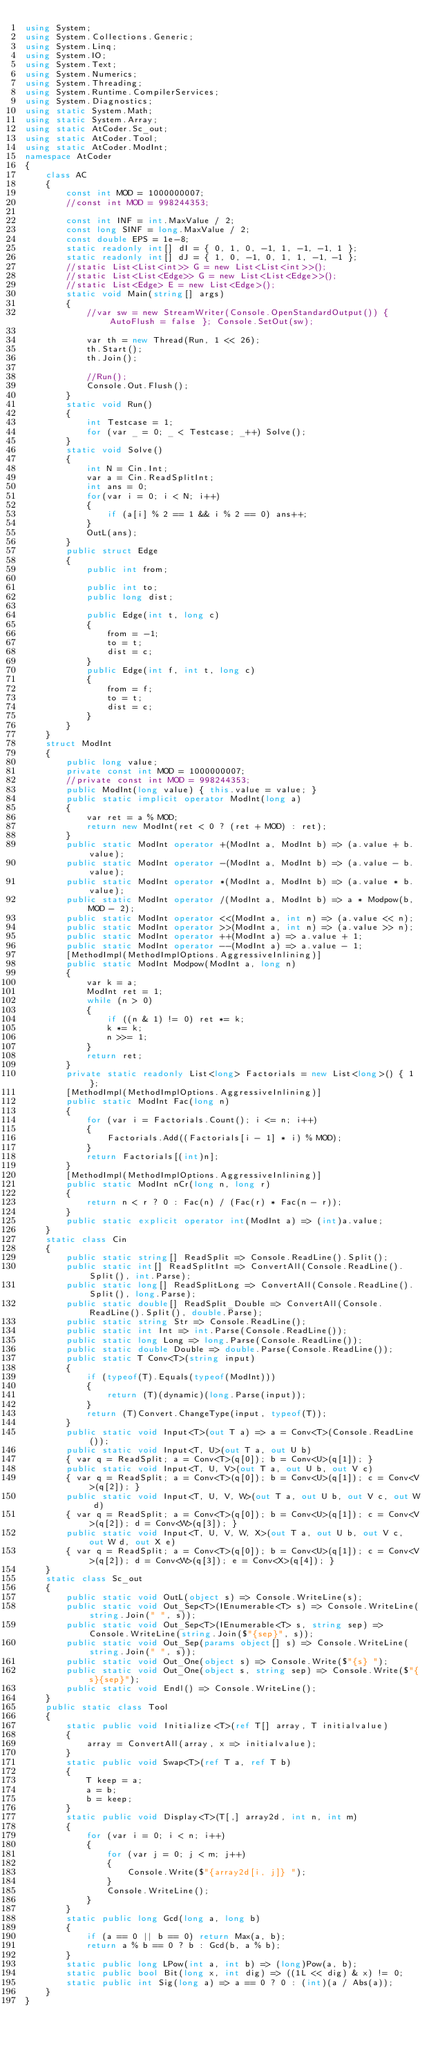<code> <loc_0><loc_0><loc_500><loc_500><_C#_>using System;
using System.Collections.Generic;
using System.Linq;
using System.IO;
using System.Text;
using System.Numerics;
using System.Threading;
using System.Runtime.CompilerServices;
using System.Diagnostics;
using static System.Math;
using static System.Array;
using static AtCoder.Sc_out;
using static AtCoder.Tool;
using static AtCoder.ModInt;
namespace AtCoder
{
    class AC
    {
        const int MOD = 1000000007;
        //const int MOD = 998244353;

        const int INF = int.MaxValue / 2;
        const long SINF = long.MaxValue / 2;
        const double EPS = 1e-8;
        static readonly int[] dI = { 0, 1, 0, -1, 1, -1, -1, 1 };
        static readonly int[] dJ = { 1, 0, -1, 0, 1, 1, -1, -1 };
        //static List<List<int>> G = new List<List<int>>();
        //static List<List<Edge>> G = new List<List<Edge>>();
        //static List<Edge> E = new List<Edge>();
        static void Main(string[] args)
        {
            //var sw = new StreamWriter(Console.OpenStandardOutput()) { AutoFlush = false }; Console.SetOut(sw);

            var th = new Thread(Run, 1 << 26);
            th.Start();
            th.Join();

            //Run();
            Console.Out.Flush();
        }
        static void Run()
        {
            int Testcase = 1;
            for (var _ = 0; _ < Testcase; _++) Solve();
        }
        static void Solve()
        {
            int N = Cin.Int;
            var a = Cin.ReadSplitInt;
            int ans = 0;
            for(var i = 0; i < N; i++)
            {
                if (a[i] % 2 == 1 && i % 2 == 0) ans++;
            }
            OutL(ans);
        }
        public struct Edge
        {
            public int from;

            public int to;
            public long dist;

            public Edge(int t, long c)
            {
                from = -1;
                to = t;
                dist = c;
            }
            public Edge(int f, int t, long c)
            {
                from = f;
                to = t;
                dist = c;
            }
        }
    }
    struct ModInt
    {
        public long value;
        private const int MOD = 1000000007;
        //private const int MOD = 998244353;
        public ModInt(long value) { this.value = value; }
        public static implicit operator ModInt(long a)
        {
            var ret = a % MOD;
            return new ModInt(ret < 0 ? (ret + MOD) : ret);
        }
        public static ModInt operator +(ModInt a, ModInt b) => (a.value + b.value);
        public static ModInt operator -(ModInt a, ModInt b) => (a.value - b.value);
        public static ModInt operator *(ModInt a, ModInt b) => (a.value * b.value);
        public static ModInt operator /(ModInt a, ModInt b) => a * Modpow(b, MOD - 2);
        public static ModInt operator <<(ModInt a, int n) => (a.value << n);
        public static ModInt operator >>(ModInt a, int n) => (a.value >> n);
        public static ModInt operator ++(ModInt a) => a.value + 1;
        public static ModInt operator --(ModInt a) => a.value - 1;
        [MethodImpl(MethodImplOptions.AggressiveInlining)]
        public static ModInt Modpow(ModInt a, long n)
        {
            var k = a;
            ModInt ret = 1;
            while (n > 0)
            {
                if ((n & 1) != 0) ret *= k;
                k *= k;
                n >>= 1;
            }
            return ret;
        }
        private static readonly List<long> Factorials = new List<long>() { 1 };
        [MethodImpl(MethodImplOptions.AggressiveInlining)]
        public static ModInt Fac(long n)
        {
            for (var i = Factorials.Count(); i <= n; i++)
            {
                Factorials.Add((Factorials[i - 1] * i) % MOD);
            }
            return Factorials[(int)n];
        }
        [MethodImpl(MethodImplOptions.AggressiveInlining)]
        public static ModInt nCr(long n, long r)
        {
            return n < r ? 0 : Fac(n) / (Fac(r) * Fac(n - r));
        }
        public static explicit operator int(ModInt a) => (int)a.value;
    }
    static class Cin
    {
        public static string[] ReadSplit => Console.ReadLine().Split();
        public static int[] ReadSplitInt => ConvertAll(Console.ReadLine().Split(), int.Parse);
        public static long[] ReadSplitLong => ConvertAll(Console.ReadLine().Split(), long.Parse);
        public static double[] ReadSplit_Double => ConvertAll(Console.ReadLine().Split(), double.Parse);
        public static string Str => Console.ReadLine();
        public static int Int => int.Parse(Console.ReadLine());
        public static long Long => long.Parse(Console.ReadLine());
        public static double Double => double.Parse(Console.ReadLine());
        public static T Conv<T>(string input)
        {
            if (typeof(T).Equals(typeof(ModInt)))
            {
                return (T)(dynamic)(long.Parse(input));
            }
            return (T)Convert.ChangeType(input, typeof(T));
        }
        public static void Input<T>(out T a) => a = Conv<T>(Console.ReadLine());
        public static void Input<T, U>(out T a, out U b)
        { var q = ReadSplit; a = Conv<T>(q[0]); b = Conv<U>(q[1]); }
        public static void Input<T, U, V>(out T a, out U b, out V c)
        { var q = ReadSplit; a = Conv<T>(q[0]); b = Conv<U>(q[1]); c = Conv<V>(q[2]); }
        public static void Input<T, U, V, W>(out T a, out U b, out V c, out W d)
        { var q = ReadSplit; a = Conv<T>(q[0]); b = Conv<U>(q[1]); c = Conv<V>(q[2]); d = Conv<W>(q[3]); }
        public static void Input<T, U, V, W, X>(out T a, out U b, out V c, out W d, out X e)
        { var q = ReadSplit; a = Conv<T>(q[0]); b = Conv<U>(q[1]); c = Conv<V>(q[2]); d = Conv<W>(q[3]); e = Conv<X>(q[4]); }
    }
    static class Sc_out
    {
        public static void OutL(object s) => Console.WriteLine(s);
        public static void Out_Sep<T>(IEnumerable<T> s) => Console.WriteLine(string.Join(" ", s));
        public static void Out_Sep<T>(IEnumerable<T> s, string sep) => Console.WriteLine(string.Join($"{sep}", s));
        public static void Out_Sep(params object[] s) => Console.WriteLine(string.Join(" ", s));
        public static void Out_One(object s) => Console.Write($"{s} ");
        public static void Out_One(object s, string sep) => Console.Write($"{s}{sep}");
        public static void Endl() => Console.WriteLine();
    }
    public static class Tool
    {
        static public void Initialize<T>(ref T[] array, T initialvalue)
        {
            array = ConvertAll(array, x => initialvalue);
        }
        static public void Swap<T>(ref T a, ref T b)
        {
            T keep = a;
            a = b;
            b = keep;
        }
        static public void Display<T>(T[,] array2d, int n, int m)
        {
            for (var i = 0; i < n; i++)
            {
                for (var j = 0; j < m; j++)
                {
                    Console.Write($"{array2d[i, j]} ");
                }
                Console.WriteLine();
            }
        }
        static public long Gcd(long a, long b)
        {
            if (a == 0 || b == 0) return Max(a, b);
            return a % b == 0 ? b : Gcd(b, a % b);
        }
        static public long LPow(int a, int b) => (long)Pow(a, b);
        static public bool Bit(long x, int dig) => ((1L << dig) & x) != 0;
        static public int Sig(long a) => a == 0 ? 0 : (int)(a / Abs(a));
    }
}
</code> 